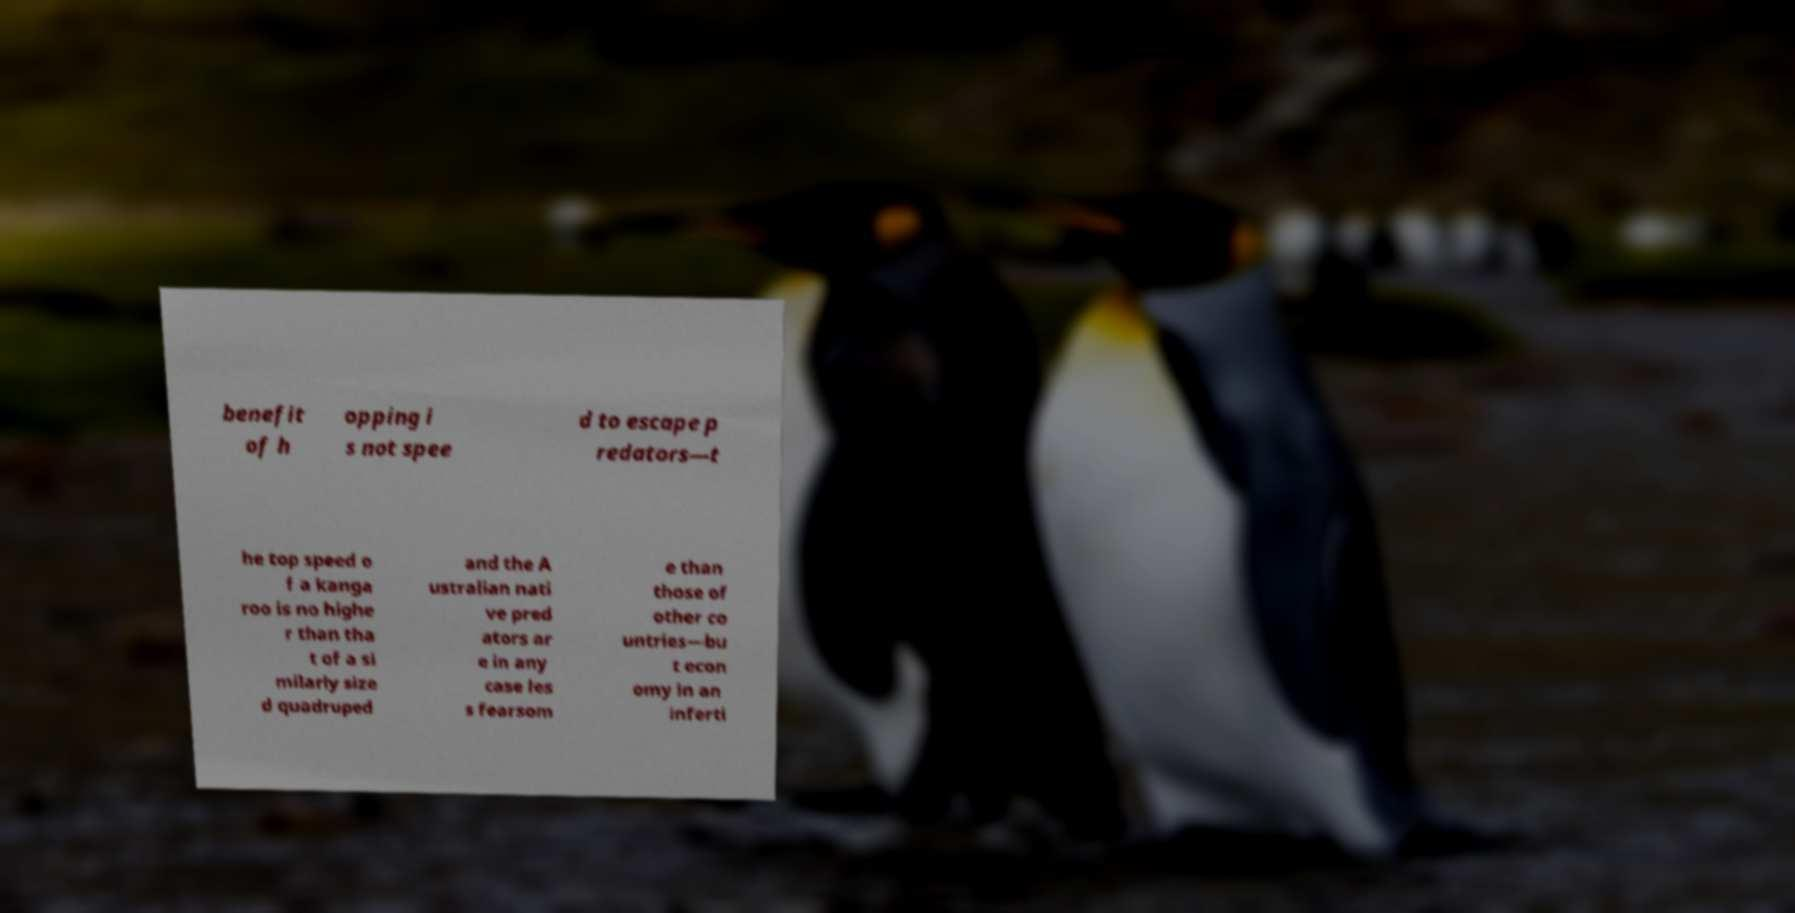Please read and relay the text visible in this image. What does it say? benefit of h opping i s not spee d to escape p redators—t he top speed o f a kanga roo is no highe r than tha t of a si milarly size d quadruped and the A ustralian nati ve pred ators ar e in any case les s fearsom e than those of other co untries—bu t econ omy in an inferti 